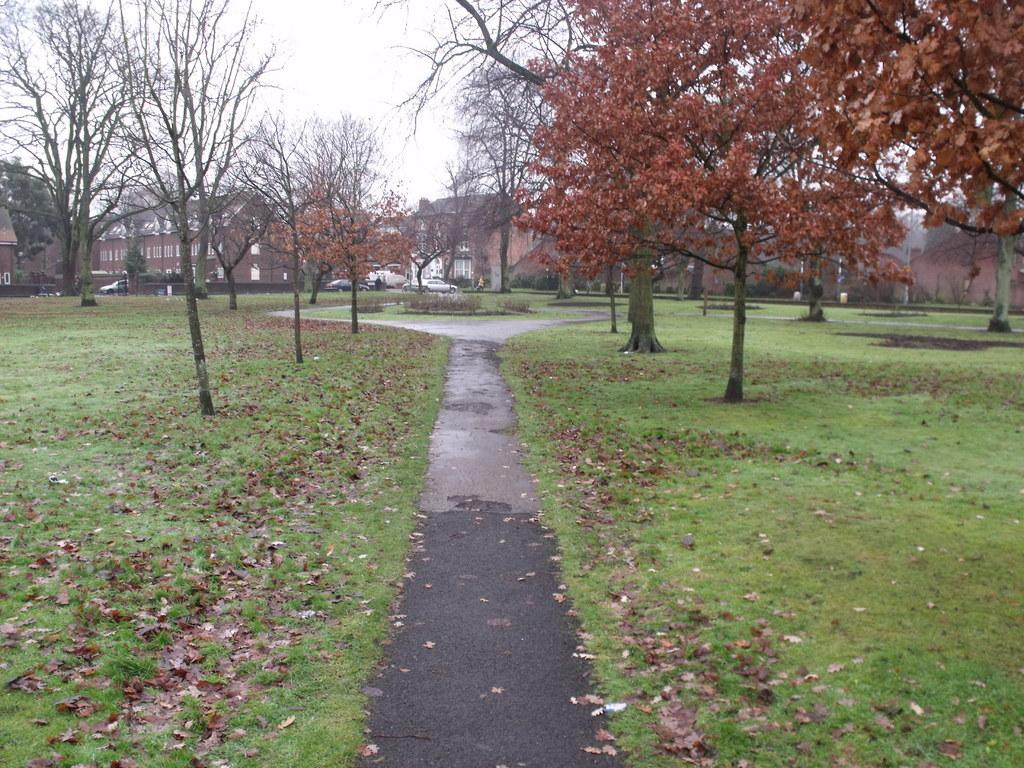What is present on the grassy land in the image? There are dry leaves on the grassy land in the image. What type of vegetation can be seen in the image? There are trees in the image. What type of man-made structures are visible in the image? There are cars and houses in the image. What is the color of the sky in the image? The sky appears to be white in color. Can you see a deer interacting with the cars in the image? There is no deer present in the image. What type of business is being conducted in the image? The image does not depict any business activities. 